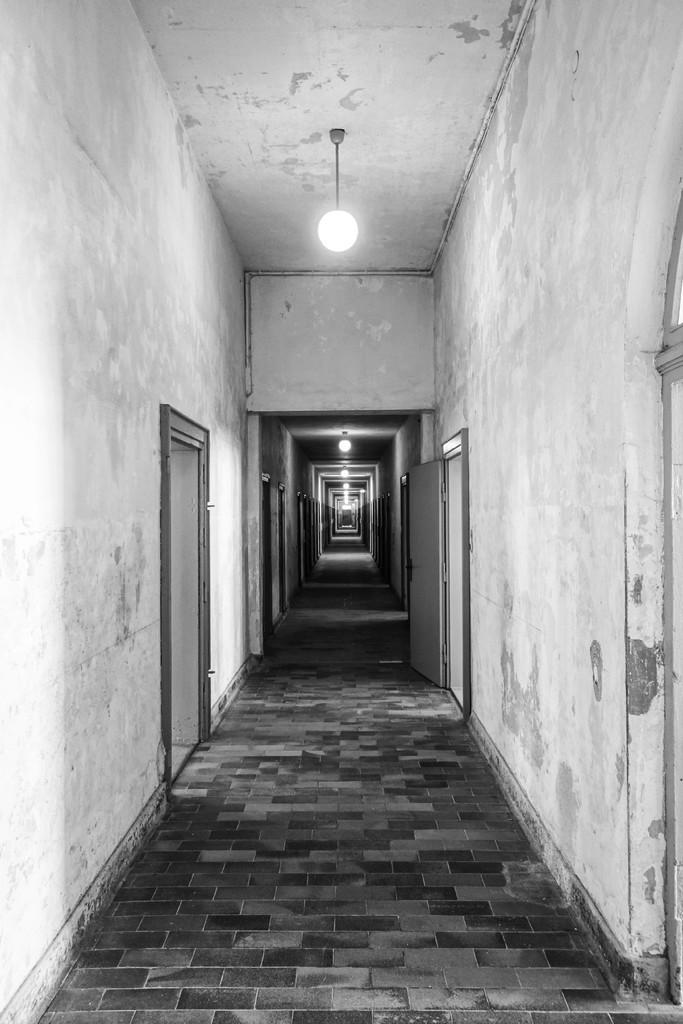Can you describe this image briefly? In this image we can see the wall and both the sides there are doors and at the top we can see the lights. 